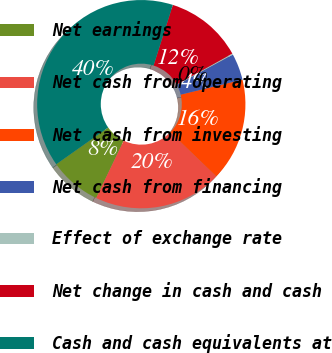Convert chart to OTSL. <chart><loc_0><loc_0><loc_500><loc_500><pie_chart><fcel>Net earnings<fcel>Net cash from operating<fcel>Net cash from investing<fcel>Net cash from financing<fcel>Effect of exchange rate<fcel>Net change in cash and cash<fcel>Cash and cash equivalents at<nl><fcel>8.08%<fcel>19.93%<fcel>15.98%<fcel>4.12%<fcel>0.17%<fcel>12.03%<fcel>39.69%<nl></chart> 